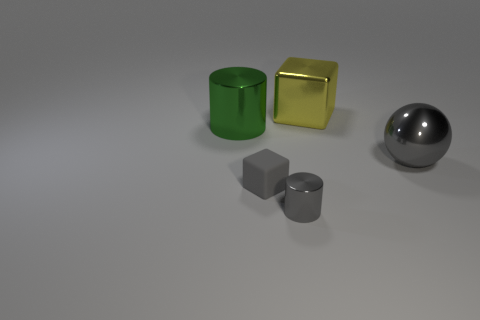There is a block in front of the big green object; does it have the same color as the tiny cylinder?
Provide a succinct answer. Yes. Does the metallic object that is in front of the gray sphere have the same size as the yellow metallic thing?
Your response must be concise. No. What is the gray cube made of?
Ensure brevity in your answer.  Rubber. The big object that is on the left side of the large metal cube is what color?
Your answer should be very brief. Green. What number of small things are either gray cylinders or cubes?
Keep it short and to the point. 2. There is a block that is on the left side of the gray shiny cylinder; is it the same color as the ball behind the small gray cube?
Your response must be concise. Yes. What number of other objects are there of the same color as the ball?
Offer a terse response. 2. What number of green things are either shiny objects or small blocks?
Your answer should be compact. 1. There is a tiny matte thing; is it the same shape as the metallic object behind the big green object?
Offer a terse response. Yes. There is a big yellow thing; what shape is it?
Provide a short and direct response. Cube. 